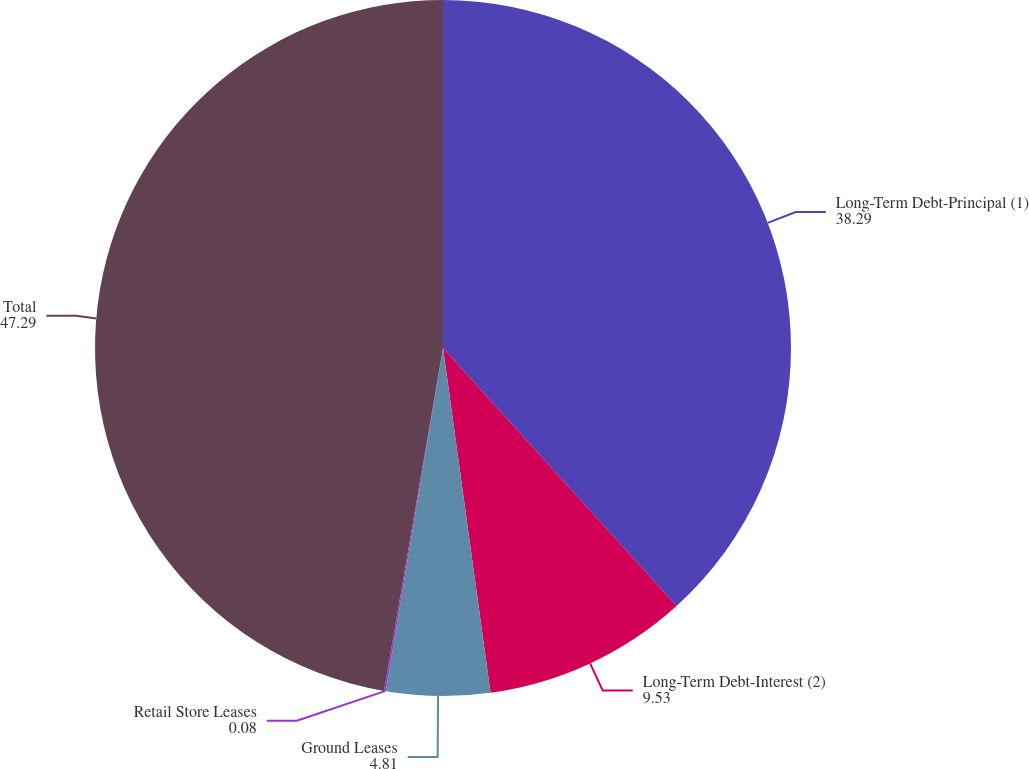<chart> <loc_0><loc_0><loc_500><loc_500><pie_chart><fcel>Long-Term Debt-Principal (1)<fcel>Long-Term Debt-Interest (2)<fcel>Ground Leases<fcel>Retail Store Leases<fcel>Total<nl><fcel>38.29%<fcel>9.53%<fcel>4.81%<fcel>0.08%<fcel>47.29%<nl></chart> 